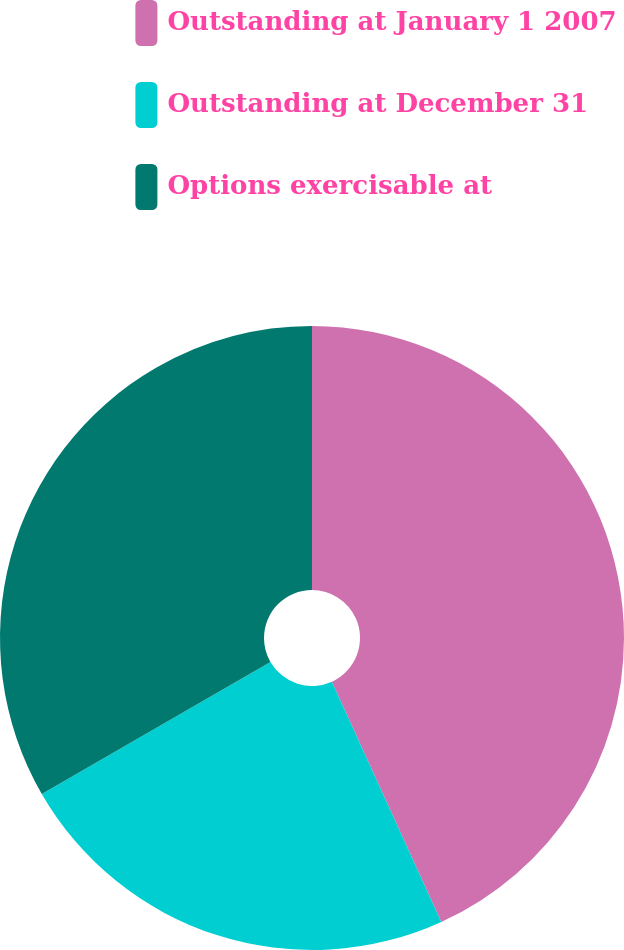<chart> <loc_0><loc_0><loc_500><loc_500><pie_chart><fcel>Outstanding at January 1 2007<fcel>Outstanding at December 31<fcel>Options exercisable at<nl><fcel>43.2%<fcel>23.47%<fcel>33.33%<nl></chart> 